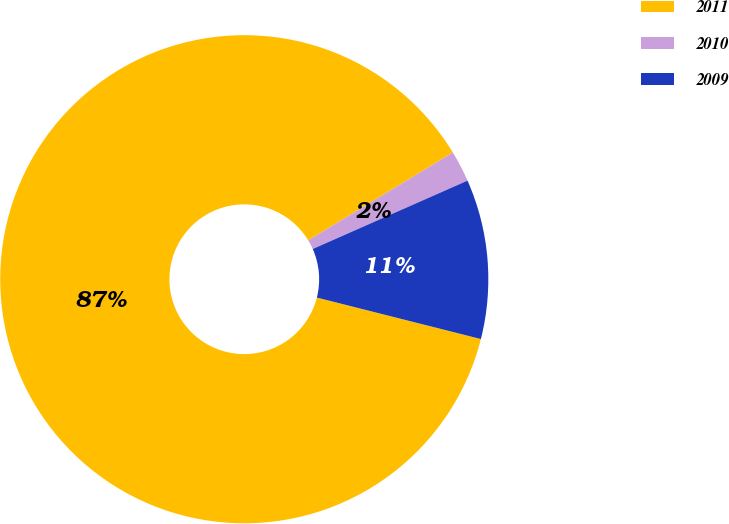<chart> <loc_0><loc_0><loc_500><loc_500><pie_chart><fcel>2011<fcel>2010<fcel>2009<nl><fcel>87.37%<fcel>2.07%<fcel>10.56%<nl></chart> 